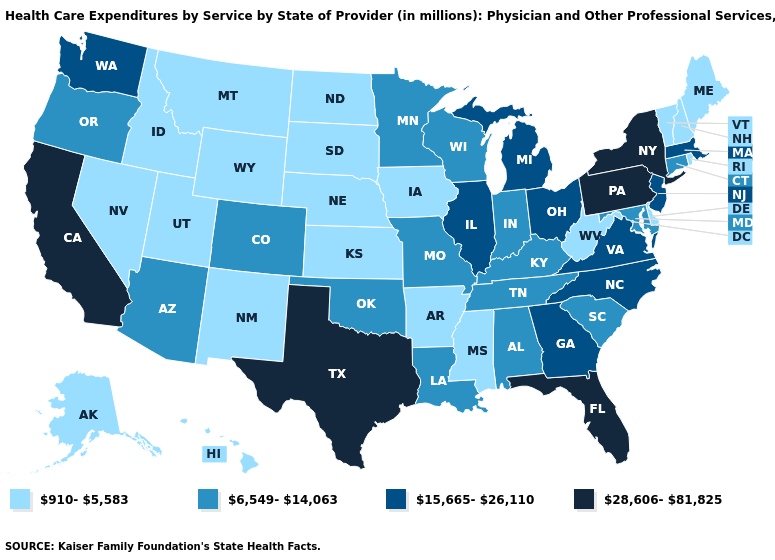Is the legend a continuous bar?
Keep it brief. No. What is the value of New Hampshire?
Quick response, please. 910-5,583. Does California have the lowest value in the West?
Keep it brief. No. Among the states that border Iowa , does Missouri have the lowest value?
Write a very short answer. No. Among the states that border Maryland , does West Virginia have the lowest value?
Write a very short answer. Yes. What is the value of Missouri?
Answer briefly. 6,549-14,063. Does Delaware have the lowest value in the USA?
Answer briefly. Yes. Name the states that have a value in the range 28,606-81,825?
Concise answer only. California, Florida, New York, Pennsylvania, Texas. Name the states that have a value in the range 15,665-26,110?
Give a very brief answer. Georgia, Illinois, Massachusetts, Michigan, New Jersey, North Carolina, Ohio, Virginia, Washington. Does New Mexico have a higher value than Wisconsin?
Quick response, please. No. Does Ohio have the highest value in the MidWest?
Short answer required. Yes. What is the value of Georgia?
Concise answer only. 15,665-26,110. What is the lowest value in the USA?
Concise answer only. 910-5,583. What is the value of Minnesota?
Give a very brief answer. 6,549-14,063. 